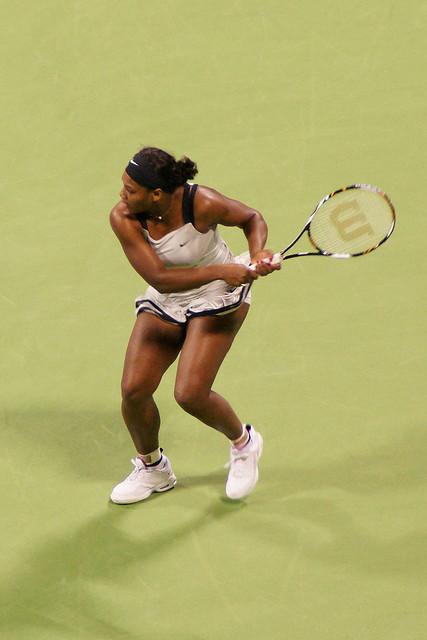What sport is the woman playing?
Short answer required. Tennis. How many people are standing?
Keep it brief. 1. Is this an Olympic tennis match?
Answer briefly. No. Does the athlete appear to be suffering from sunburn?
Quick response, please. No. How much of her legs does the bottom part of her skirt cover?
Answer briefly. Little. 